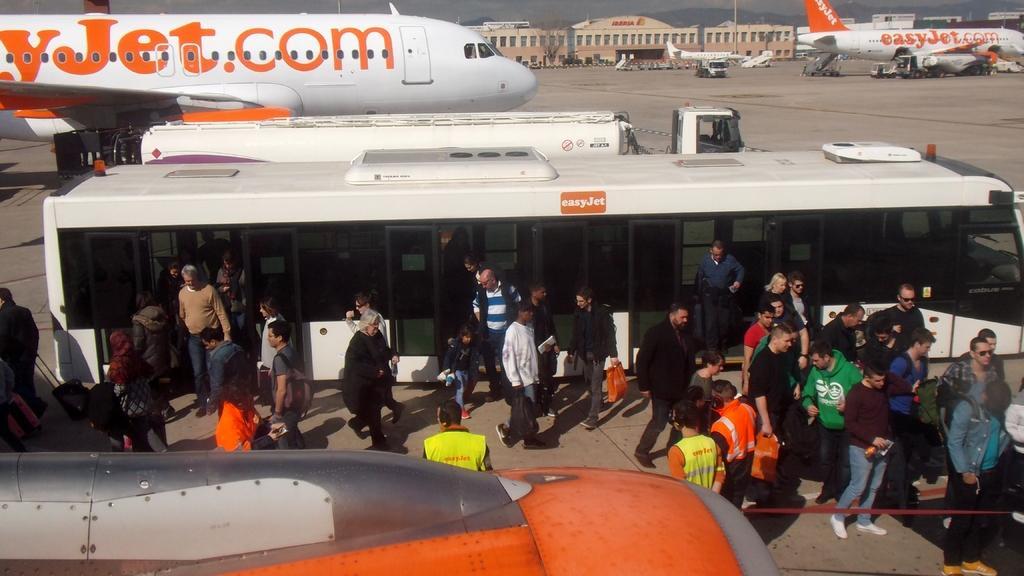Could you give a brief overview of what you see in this image? In this image there are group of people standing near the bus, and at the background there are airplanes on the runway, vehicles, airport, poles , sky. 